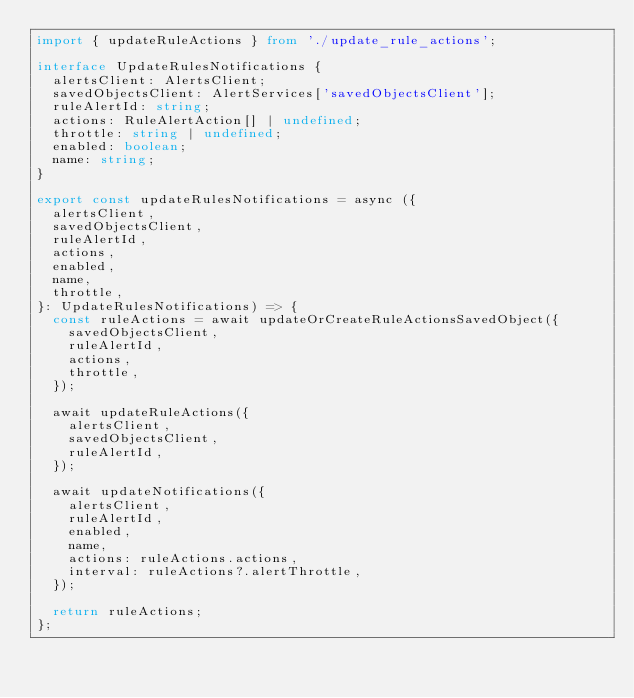<code> <loc_0><loc_0><loc_500><loc_500><_TypeScript_>import { updateRuleActions } from './update_rule_actions';

interface UpdateRulesNotifications {
  alertsClient: AlertsClient;
  savedObjectsClient: AlertServices['savedObjectsClient'];
  ruleAlertId: string;
  actions: RuleAlertAction[] | undefined;
  throttle: string | undefined;
  enabled: boolean;
  name: string;
}

export const updateRulesNotifications = async ({
  alertsClient,
  savedObjectsClient,
  ruleAlertId,
  actions,
  enabled,
  name,
  throttle,
}: UpdateRulesNotifications) => {
  const ruleActions = await updateOrCreateRuleActionsSavedObject({
    savedObjectsClient,
    ruleAlertId,
    actions,
    throttle,
  });

  await updateRuleActions({
    alertsClient,
    savedObjectsClient,
    ruleAlertId,
  });

  await updateNotifications({
    alertsClient,
    ruleAlertId,
    enabled,
    name,
    actions: ruleActions.actions,
    interval: ruleActions?.alertThrottle,
  });

  return ruleActions;
};
</code> 